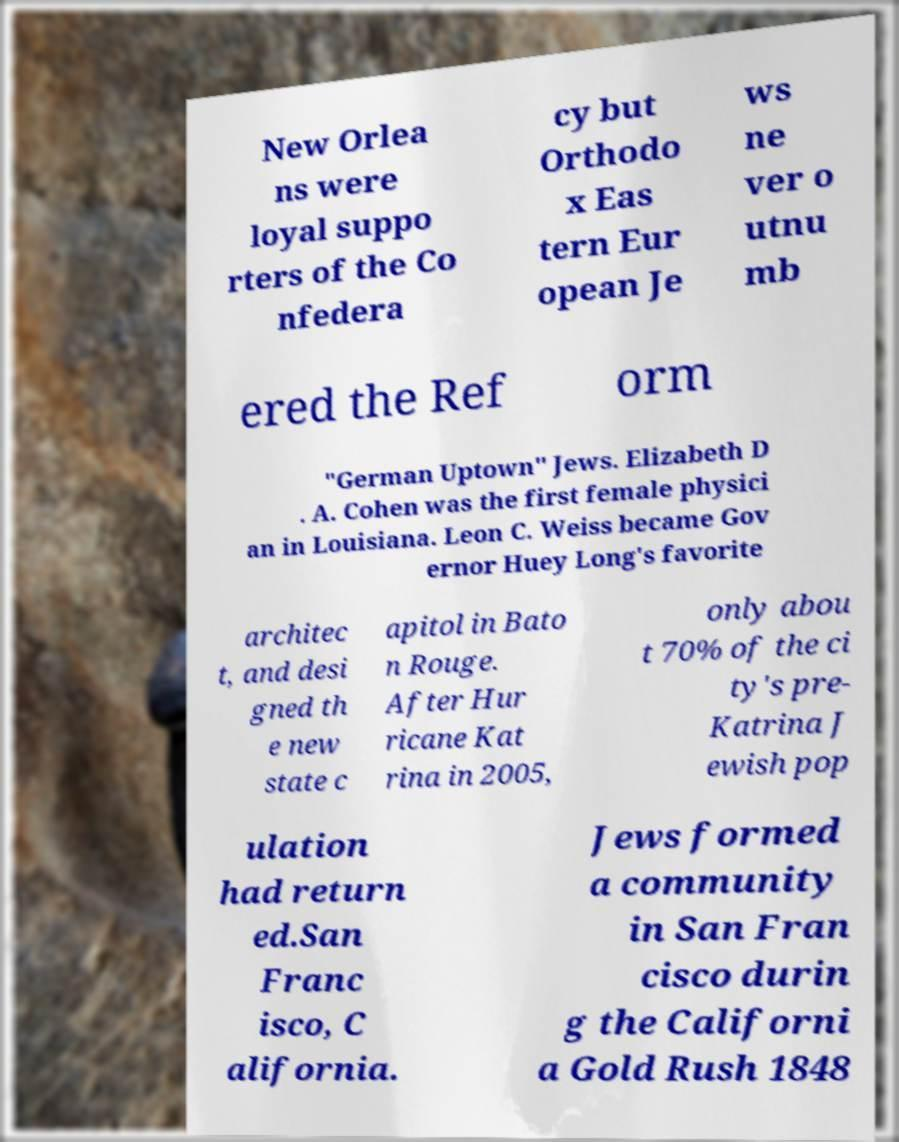Please read and relay the text visible in this image. What does it say? New Orlea ns were loyal suppo rters of the Co nfedera cy but Orthodo x Eas tern Eur opean Je ws ne ver o utnu mb ered the Ref orm "German Uptown" Jews. Elizabeth D . A. Cohen was the first female physici an in Louisiana. Leon C. Weiss became Gov ernor Huey Long's favorite architec t, and desi gned th e new state c apitol in Bato n Rouge. After Hur ricane Kat rina in 2005, only abou t 70% of the ci ty's pre- Katrina J ewish pop ulation had return ed.San Franc isco, C alifornia. Jews formed a community in San Fran cisco durin g the Californi a Gold Rush 1848 